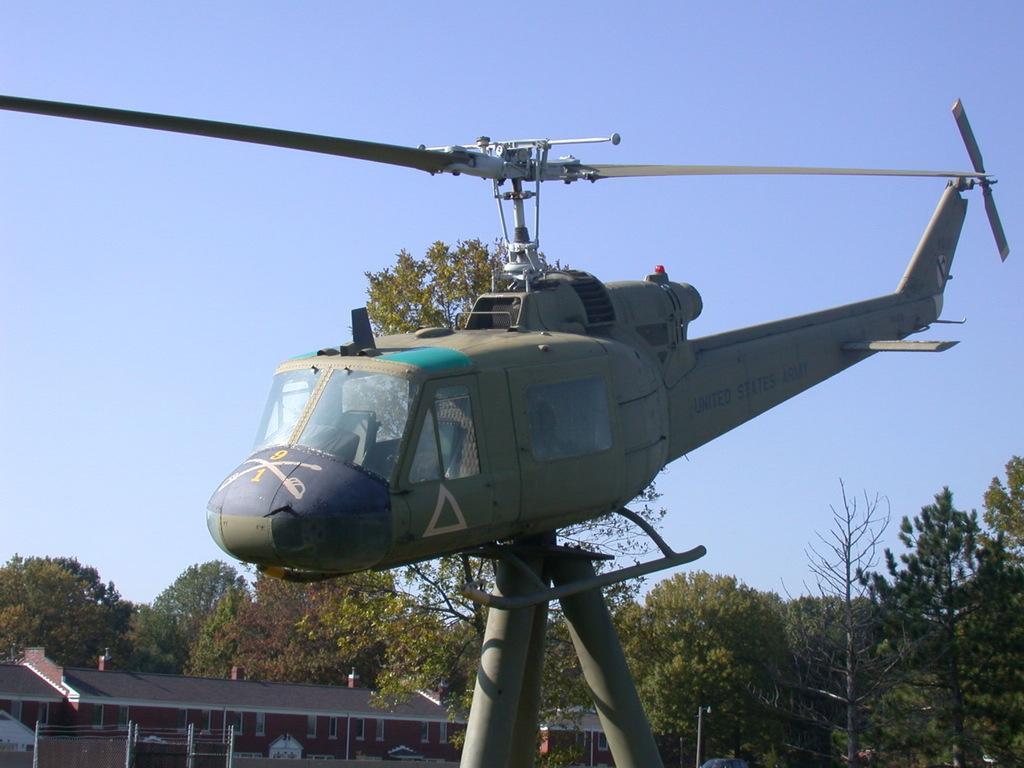Could you give a brief overview of what you see in this image? In this image in the front there is a helicopter on the poles. In the background there is a building and there are trees. 